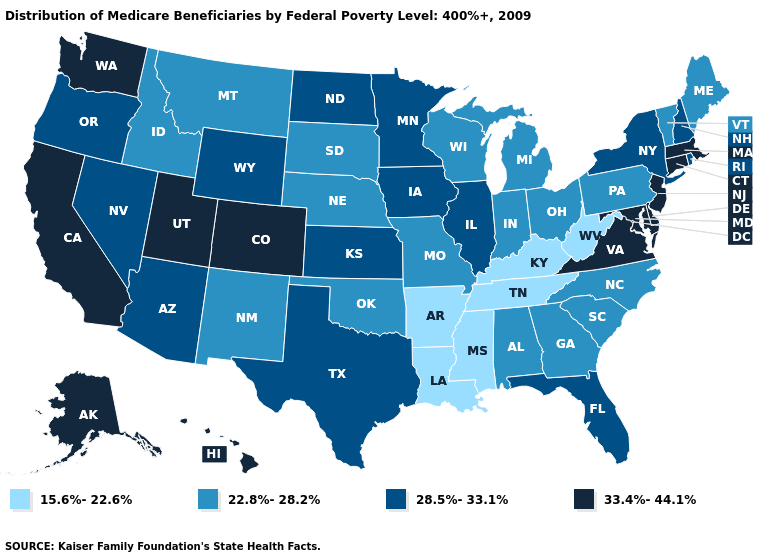What is the value of South Dakota?
Keep it brief. 22.8%-28.2%. Among the states that border New Mexico , which have the lowest value?
Quick response, please. Oklahoma. Which states hav the highest value in the MidWest?
Be succinct. Illinois, Iowa, Kansas, Minnesota, North Dakota. Does the first symbol in the legend represent the smallest category?
Short answer required. Yes. Among the states that border Washington , does Idaho have the lowest value?
Keep it brief. Yes. Does North Dakota have the highest value in the MidWest?
Write a very short answer. Yes. What is the lowest value in the USA?
Concise answer only. 15.6%-22.6%. What is the value of New York?
Answer briefly. 28.5%-33.1%. Name the states that have a value in the range 33.4%-44.1%?
Give a very brief answer. Alaska, California, Colorado, Connecticut, Delaware, Hawaii, Maryland, Massachusetts, New Jersey, Utah, Virginia, Washington. Is the legend a continuous bar?
Answer briefly. No. What is the value of Vermont?
Write a very short answer. 22.8%-28.2%. Among the states that border Louisiana , does Mississippi have the lowest value?
Write a very short answer. Yes. Which states have the lowest value in the South?
Answer briefly. Arkansas, Kentucky, Louisiana, Mississippi, Tennessee, West Virginia. 